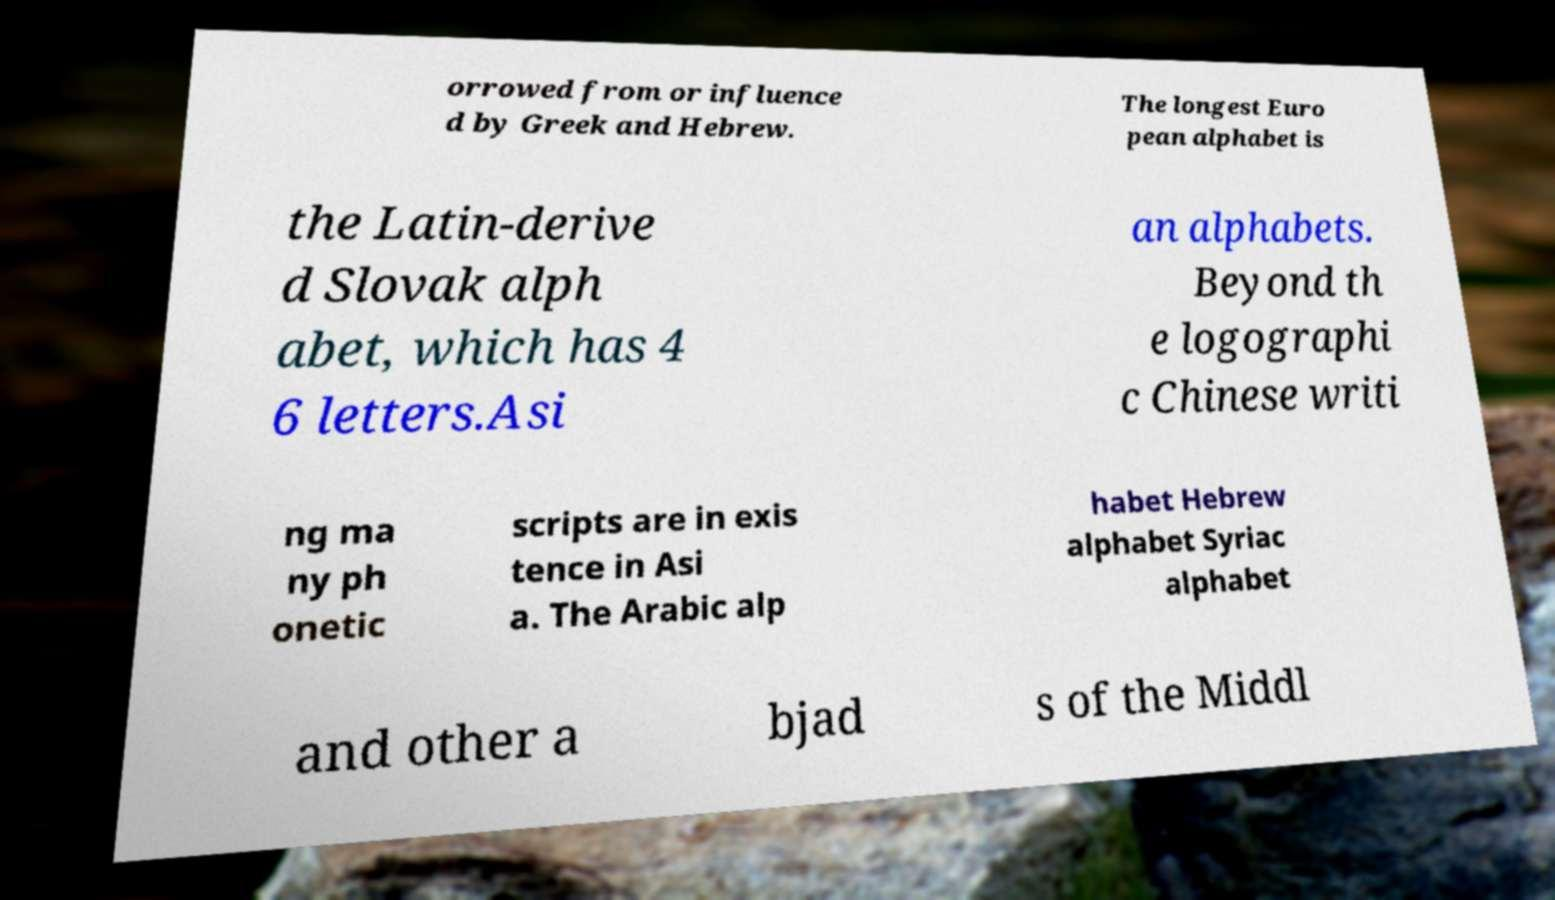Could you assist in decoding the text presented in this image and type it out clearly? orrowed from or influence d by Greek and Hebrew. The longest Euro pean alphabet is the Latin-derive d Slovak alph abet, which has 4 6 letters.Asi an alphabets. Beyond th e logographi c Chinese writi ng ma ny ph onetic scripts are in exis tence in Asi a. The Arabic alp habet Hebrew alphabet Syriac alphabet and other a bjad s of the Middl 